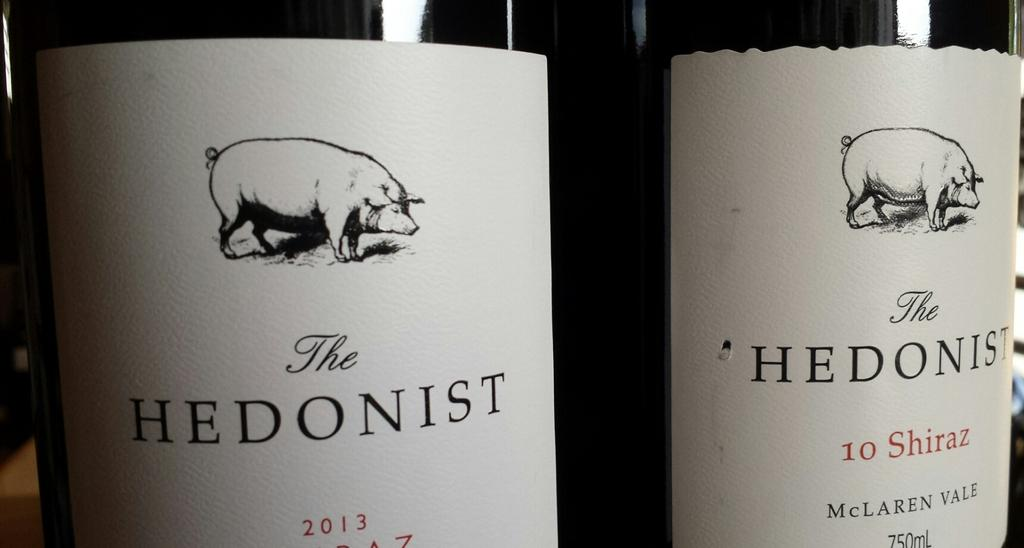How many bottles are visible in the image? There are two bottles in the image. What is depicted on the bottom of the bottles? There is an image of pigs on the bottom of the bottles. What else can be seen on the bottles besides the image of pigs? There is text written on the bottles. What type of cracker is being used to feed the sheep in the image? There are no sheep or crackers present in the image; it features two bottles with an image of pigs and text on them. 